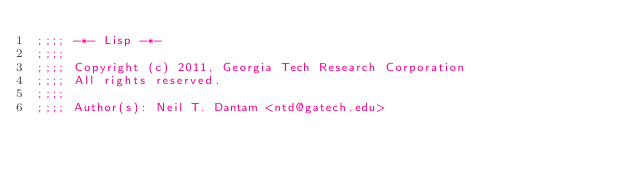Convert code to text. <code><loc_0><loc_0><loc_500><loc_500><_Lisp_>;;;; -*- Lisp -*-
;;;;
;;;; Copyright (c) 2011, Georgia Tech Research Corporation
;;;; All rights reserved.
;;;;
;;;; Author(s): Neil T. Dantam <ntd@gatech.edu></code> 